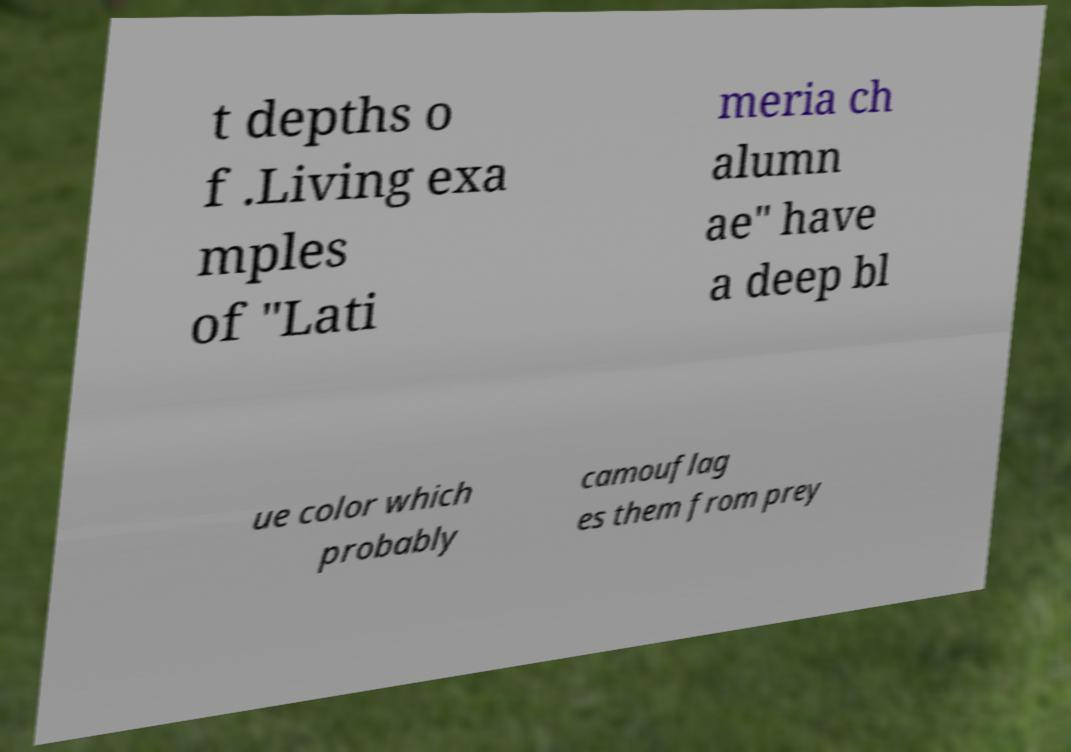What messages or text are displayed in this image? I need them in a readable, typed format. t depths o f .Living exa mples of "Lati meria ch alumn ae" have a deep bl ue color which probably camouflag es them from prey 